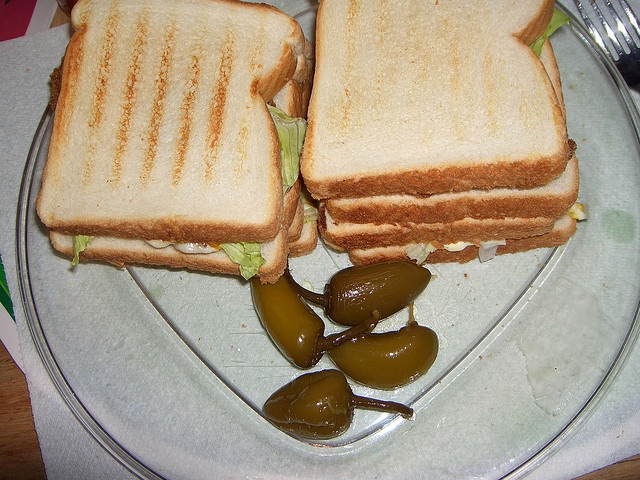Describe the objects in this image and their specific colors. I can see sandwich in maroon and tan tones, sandwich in maroon, tan, and brown tones, dining table in maroon, black, and brown tones, and fork in maroon, black, gray, white, and darkgray tones in this image. 